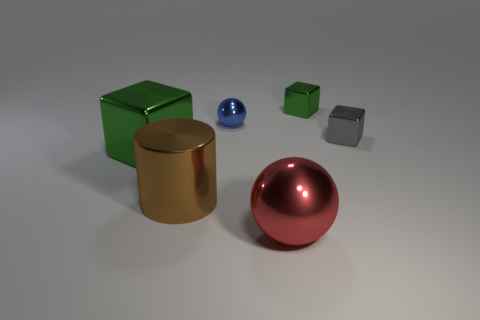There is a object that is the same color as the large shiny cube; what material is it?
Provide a short and direct response. Metal. There is a green object behind the green metal thing on the left side of the cylinder; what is its size?
Your response must be concise. Small. Are there any things that have the same material as the large brown cylinder?
Provide a succinct answer. Yes. What material is the sphere that is the same size as the brown object?
Provide a short and direct response. Metal. There is a block that is in front of the small gray cube; is it the same color as the tiny shiny thing that is behind the tiny blue object?
Make the answer very short. Yes. There is a green block that is to the right of the blue metal sphere; is there a tiny green object in front of it?
Your answer should be very brief. No. There is a large metal thing on the left side of the big cylinder; is it the same shape as the green thing on the right side of the red metallic sphere?
Your response must be concise. Yes. Is the material of the big thing that is on the right side of the big brown metal thing the same as the sphere behind the large block?
Provide a succinct answer. Yes. There is a tiny cube behind the tiny shiny object that is in front of the blue metal thing; what is its material?
Keep it short and to the point. Metal. There is a object to the right of the green shiny object on the right side of the green metal block that is left of the tiny blue ball; what shape is it?
Keep it short and to the point. Cube. 